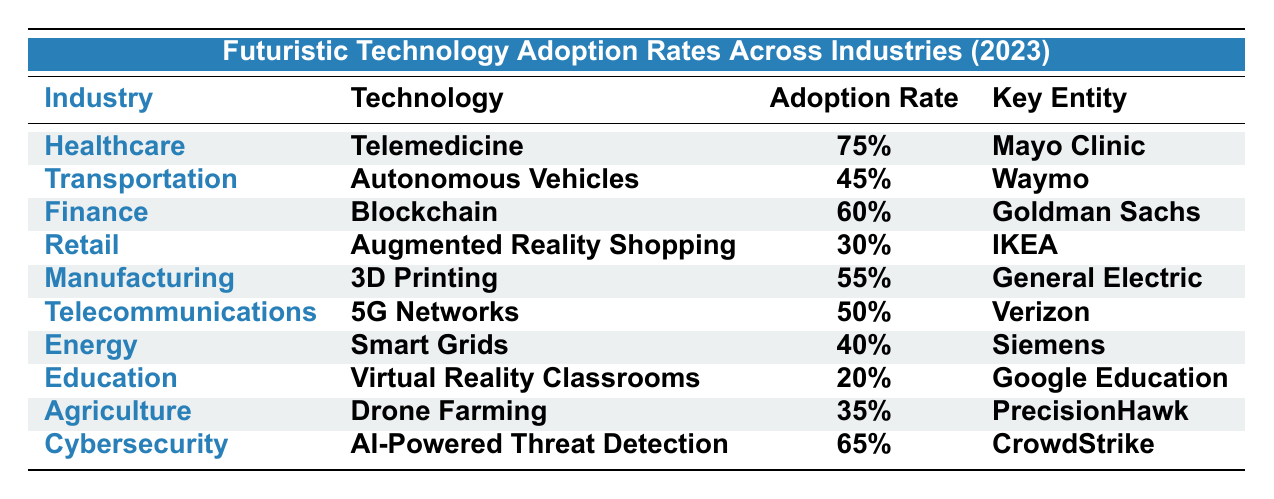What is the adoption rate of Telemedicine in Healthcare? The table lists the adoption rate of Telemedicine under the Healthcare industry, which is specified as 75%.
Answer: 75% Which industry has the highest adoption rate for futuristic technology? By comparing all the adoption rates listed, Healthcare with Telemedicine at 75% has the highest rate.
Answer: Healthcare What is the technology used in Agriculture and its adoption rate? The table shows that the technology used in Agriculture is Drone Farming, with an adoption rate of 35%.
Answer: Drone Farming, 35% Which two industries have an adoption rate greater than 60%? According to the table, only the Healthcare industry (75%) and Cybersecurity (65%) exceed the 60% mark in adoption rates.
Answer: Healthcare, Cybersecurity What is the difference in adoption rates between Finance and Retail? The adoption rate for Finance (60%) minus the adoption rate for Retail (30%) gives a difference of 30%.
Answer: 30% What percentage of industries listed have an adoption rate below 40%? There are two industries (Energy at 40% and Education at 20%) with adoption rates below 40%. So, 2 out of 10 industries result in 20%.
Answer: 20% Is the adoption rate of 5G Networks higher than that of Smart Grids? Yes, 5G Networks (50%) has a higher adoption rate compared to Smart Grids (40%), so the statement is true.
Answer: Yes How does the adoption rate of Autonomous Vehicles compare to that of Augmented Reality Shopping? The adoption rate for Autonomous Vehicles is 45%, while for Augmented Reality Shopping, it is 30%. Therefore, Autonomous Vehicles have a higher adoption rate.
Answer: Autonomous Vehicles are higher If we average the adoption rates of the top three industries, what is the result? The adoption rates of the top three industries are Healthcare (75%), Cybersecurity (65%), and Finance (60%). The average is (75 + 65 + 60) / 3 = 66.67%.
Answer: 66.67% Which industry has the lowest adoption rate and what is its value? By examining the table, Education has the lowest adoption rate at 20%.
Answer: Education, 20% 